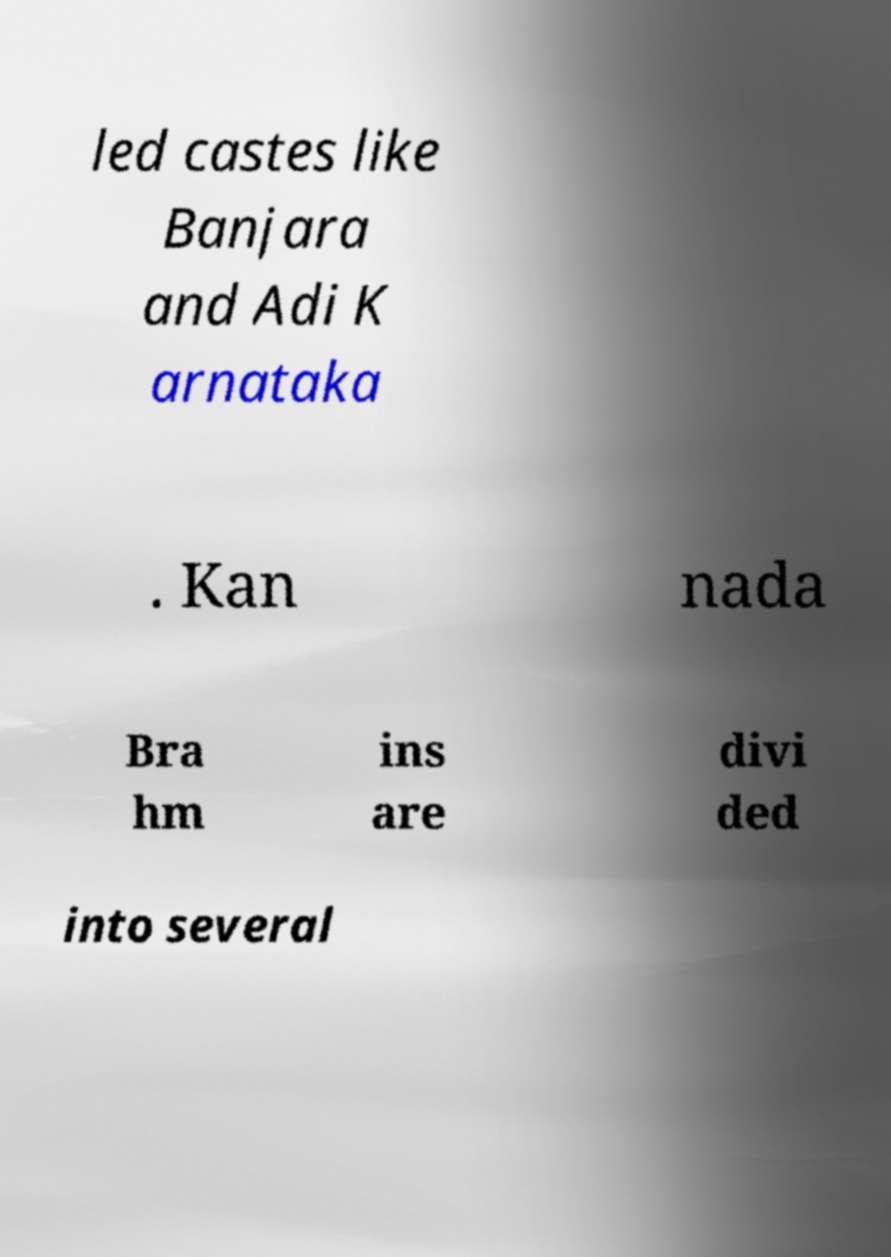Can you read and provide the text displayed in the image?This photo seems to have some interesting text. Can you extract and type it out for me? led castes like Banjara and Adi K arnataka . Kan nada Bra hm ins are divi ded into several 